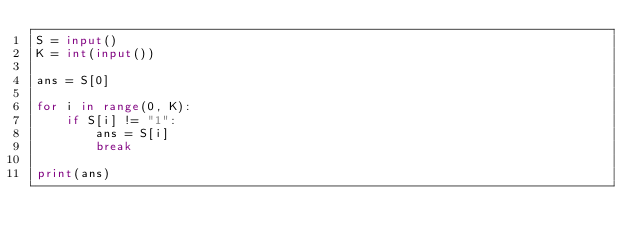Convert code to text. <code><loc_0><loc_0><loc_500><loc_500><_Python_>S = input()
K = int(input())

ans = S[0]

for i in range(0, K):
    if S[i] != "1":
        ans = S[i]
        break

print(ans)
</code> 